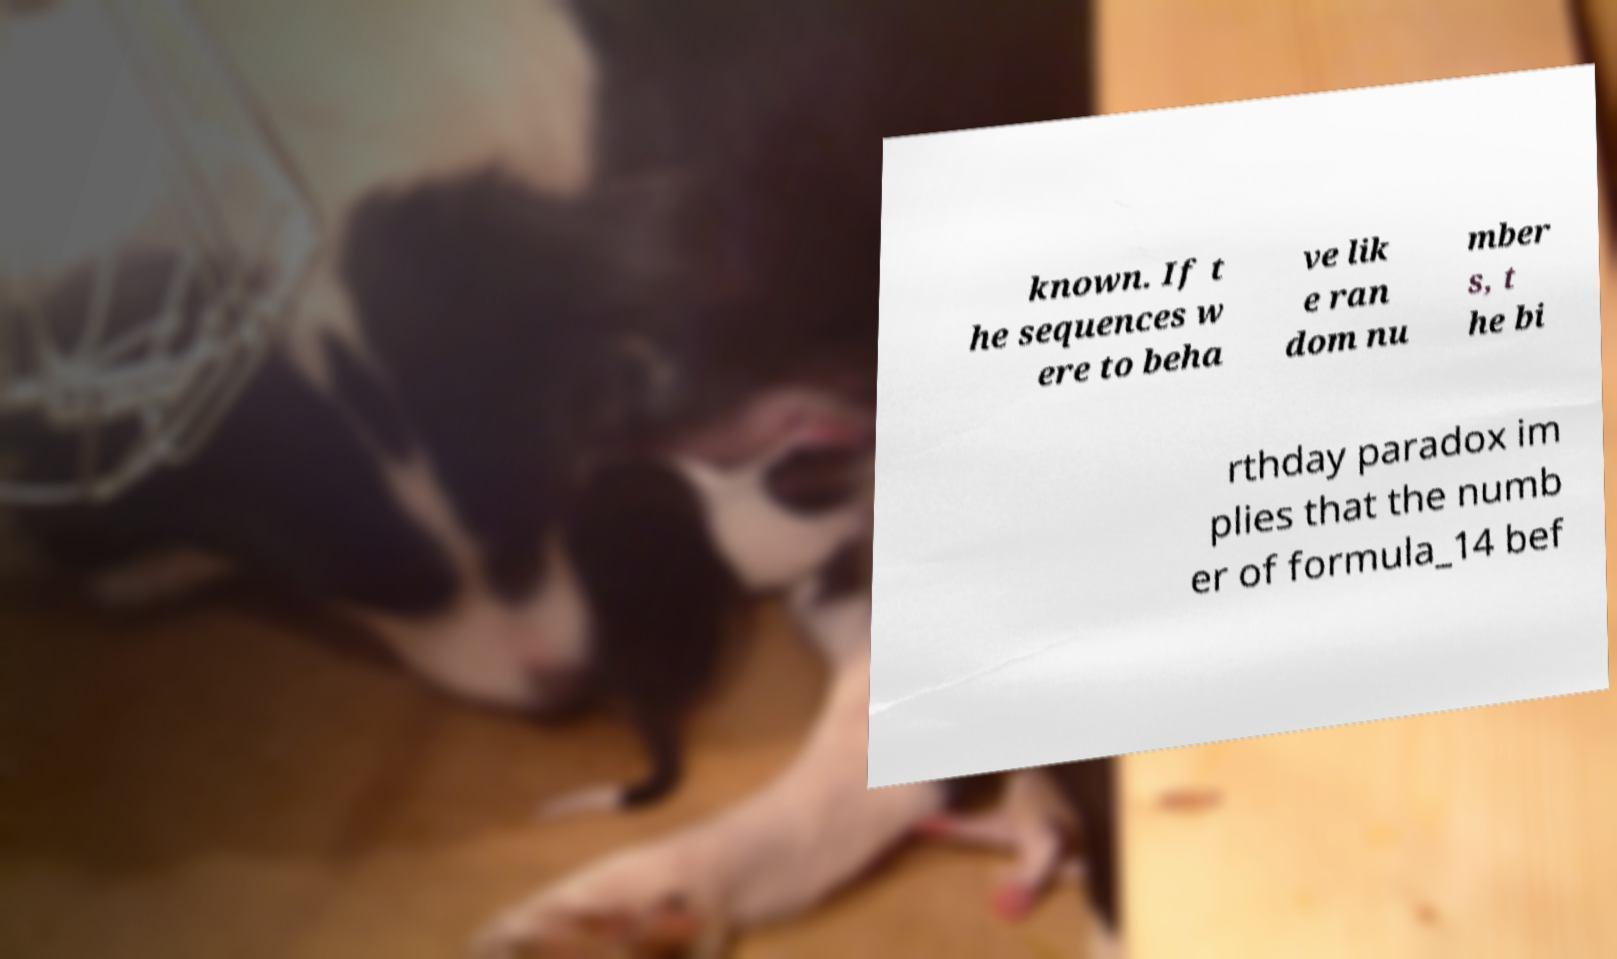Could you extract and type out the text from this image? known. If t he sequences w ere to beha ve lik e ran dom nu mber s, t he bi rthday paradox im plies that the numb er of formula_14 bef 